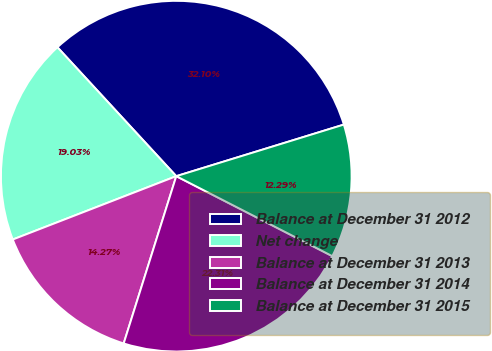Convert chart to OTSL. <chart><loc_0><loc_0><loc_500><loc_500><pie_chart><fcel>Balance at December 31 2012<fcel>Net change<fcel>Balance at December 31 2013<fcel>Balance at December 31 2014<fcel>Balance at December 31 2015<nl><fcel>32.1%<fcel>19.03%<fcel>14.27%<fcel>22.31%<fcel>12.29%<nl></chart> 